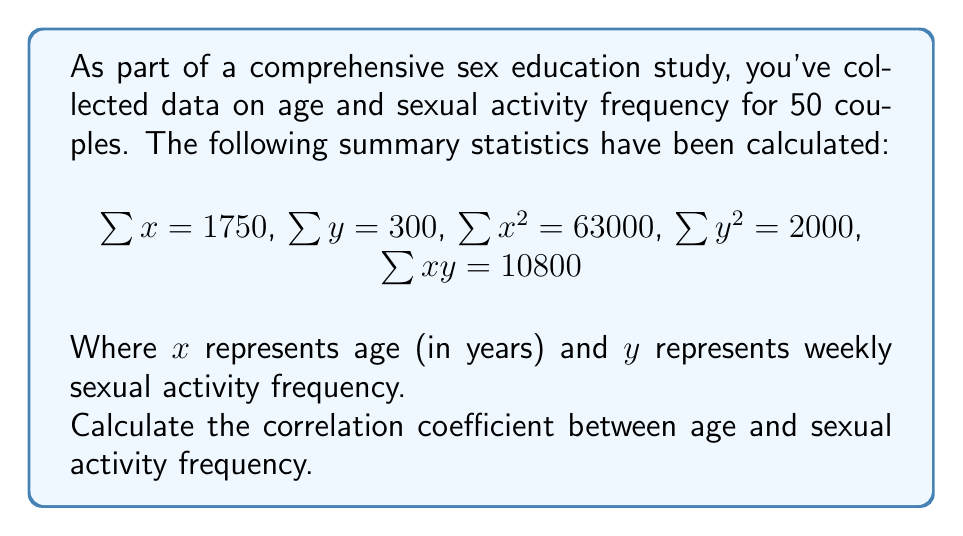What is the answer to this math problem? To calculate the correlation coefficient, we'll use the formula:

$$r = \frac{n\sum xy - \sum x \sum y}{\sqrt{[n\sum x^2 - (\sum x)^2][n\sum y^2 - (\sum y)^2]}}$$

Where $n$ is the number of couples (50 in this case).

Step 1: Calculate $n\sum xy$
$n\sum xy = 50 \times 10800 = 540000$

Step 2: Calculate $\sum x \sum y$
$\sum x \sum y = 1750 \times 300 = 525000$

Step 3: Calculate the numerator
$540000 - 525000 = 15000$

Step 4: Calculate $n\sum x^2$ and $(\sum x)^2$
$n\sum x^2 = 50 \times 63000 = 3150000$
$(\sum x)^2 = 1750^2 = 3062500$

Step 5: Calculate $n\sum y^2$ and $(\sum y)^2$
$n\sum y^2 = 50 \times 2000 = 100000$
$(\sum y)^2 = 300^2 = 90000$

Step 6: Calculate the denominator
$\sqrt{[3150000 - 3062500][100000 - 90000]}$
$= \sqrt{87500 \times 10000}$
$= \sqrt{875000000}$
$= 29580.40$

Step 7: Calculate the correlation coefficient
$r = \frac{15000}{29580.40} \approx 0.5071$
Answer: $r \approx 0.5071$ 